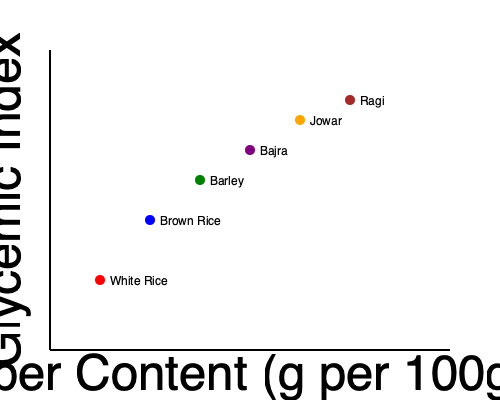Based on the scatter plot showing the relationship between fiber content and glycemic index of various South Asian grains, which grain would you recommend to clients looking to manage their blood sugar levels while increasing their fiber intake? Explain your reasoning using the concept of glycemic index and its relation to fiber content. To answer this question, we need to understand the relationship between glycemic index (GI) and fiber content, and analyze the data presented in the scatter plot. Let's break it down step-by-step:

1. Glycemic Index (GI) and its importance:
   - GI measures how quickly a food raises blood glucose levels.
   - Lower GI foods are generally better for managing blood sugar levels.
   - GI is represented on the y-axis of the scatter plot, with lower values being more desirable.

2. Fiber content and its benefits:
   - Fiber is important for digestive health and can help slow down the absorption of sugar.
   - Higher fiber content is generally associated with lower GI values.
   - Fiber content is represented on the x-axis of the scatter plot, with higher values being more desirable.

3. Analyzing the scatter plot:
   - The plot shows six South Asian grains: White Rice, Brown Rice, Barley, Bajra, Jowar, and Ragi.
   - We can observe a general trend: as fiber content increases, the glycemic index decreases.

4. Comparing the grains:
   - White Rice: Highest GI, lowest fiber content
   - Brown Rice: Lower GI than white rice, slightly higher fiber content
   - Barley: Lower GI than brown rice, higher fiber content
   - Bajra: Lower GI than barley, higher fiber content
   - Jowar: Lower GI than bajra, higher fiber content
   - Ragi: Lowest GI, highest fiber content

5. Selecting the best option:
   - Ragi (finger millet) appears to have the lowest GI and the highest fiber content among the grains shown.
   - This makes it the best choice for managing blood sugar levels while increasing fiber intake.

6. Additional considerations:
   - While Ragi is the best option based on this data, it's important to note that a balanced diet should include a variety of grains and foods.
   - Individual responses to different grains may vary, so personalized recommendations should take into account other factors such as overall health, dietary preferences, and specific health goals.
Answer: Ragi (finger millet), due to its lowest glycemic index and highest fiber content. 